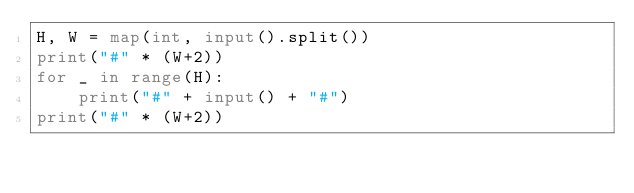<code> <loc_0><loc_0><loc_500><loc_500><_Python_>H, W = map(int, input().split())
print("#" * (W+2))
for _ in range(H):
    print("#" + input() + "#")
print("#" * (W+2))</code> 